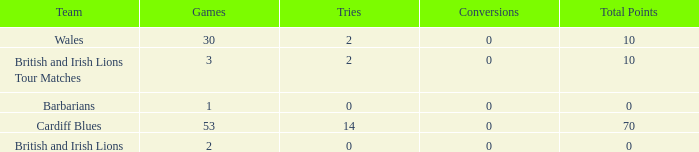What is the smallest number of tries with conversions more than 0? None. 